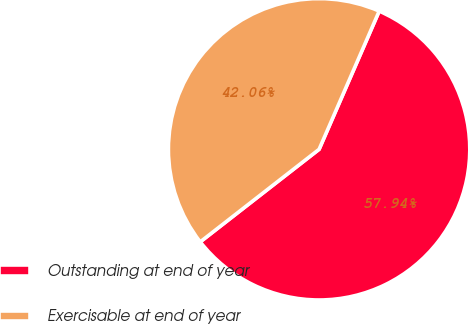<chart> <loc_0><loc_0><loc_500><loc_500><pie_chart><fcel>Outstanding at end of year<fcel>Exercisable at end of year<nl><fcel>57.94%<fcel>42.06%<nl></chart> 